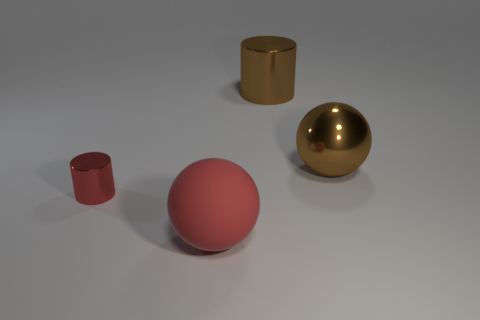Are there any other things that are made of the same material as the red sphere?
Ensure brevity in your answer.  No. Is there anything else that has the same size as the red metal cylinder?
Give a very brief answer. No. What is the color of the large metal object that is on the right side of the cylinder to the right of the red object left of the large rubber ball?
Provide a succinct answer. Brown. Is the color of the cylinder to the right of the tiny red metallic cylinder the same as the big shiny sphere?
Keep it short and to the point. Yes. What number of other things are the same color as the tiny metal object?
Make the answer very short. 1. What number of things are small cyan rubber spheres or spheres?
Offer a very short reply. 2. How many things are either cyan things or large objects that are behind the small red cylinder?
Ensure brevity in your answer.  2. Does the brown cylinder have the same material as the red sphere?
Your answer should be very brief. No. What number of other objects are the same material as the large brown sphere?
Ensure brevity in your answer.  2. Is the number of big green objects greater than the number of red shiny cylinders?
Provide a short and direct response. No. 